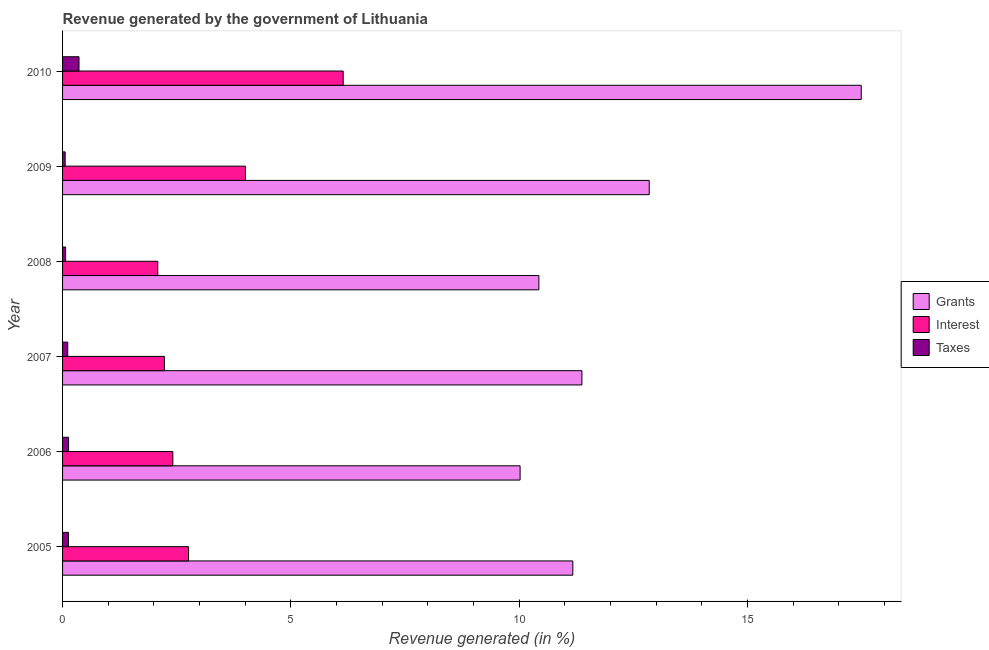How many different coloured bars are there?
Offer a terse response. 3. Are the number of bars on each tick of the Y-axis equal?
Your answer should be compact. Yes. What is the percentage of revenue generated by grants in 2006?
Provide a short and direct response. 10.02. Across all years, what is the maximum percentage of revenue generated by interest?
Make the answer very short. 6.15. Across all years, what is the minimum percentage of revenue generated by interest?
Keep it short and to the point. 2.09. In which year was the percentage of revenue generated by grants minimum?
Offer a terse response. 2006. What is the total percentage of revenue generated by grants in the graph?
Offer a terse response. 73.34. What is the difference between the percentage of revenue generated by grants in 2008 and that in 2009?
Keep it short and to the point. -2.42. What is the difference between the percentage of revenue generated by interest in 2006 and the percentage of revenue generated by grants in 2009?
Ensure brevity in your answer.  -10.43. What is the average percentage of revenue generated by taxes per year?
Offer a very short reply. 0.14. In the year 2005, what is the difference between the percentage of revenue generated by grants and percentage of revenue generated by taxes?
Offer a very short reply. 11.04. In how many years, is the percentage of revenue generated by taxes greater than 15 %?
Make the answer very short. 0. What is the ratio of the percentage of revenue generated by interest in 2005 to that in 2009?
Your answer should be very brief. 0.69. Is the percentage of revenue generated by grants in 2005 less than that in 2010?
Give a very brief answer. Yes. Is the difference between the percentage of revenue generated by taxes in 2007 and 2009 greater than the difference between the percentage of revenue generated by grants in 2007 and 2009?
Make the answer very short. Yes. What is the difference between the highest and the second highest percentage of revenue generated by interest?
Ensure brevity in your answer.  2.14. What is the difference between the highest and the lowest percentage of revenue generated by grants?
Provide a succinct answer. 7.47. In how many years, is the percentage of revenue generated by grants greater than the average percentage of revenue generated by grants taken over all years?
Keep it short and to the point. 2. What does the 3rd bar from the top in 2009 represents?
Your answer should be very brief. Grants. What does the 2nd bar from the bottom in 2006 represents?
Keep it short and to the point. Interest. How many bars are there?
Offer a very short reply. 18. Are all the bars in the graph horizontal?
Your answer should be compact. Yes. What is the difference between two consecutive major ticks on the X-axis?
Your response must be concise. 5. How many legend labels are there?
Give a very brief answer. 3. How are the legend labels stacked?
Your answer should be very brief. Vertical. What is the title of the graph?
Make the answer very short. Revenue generated by the government of Lithuania. Does "Industry" appear as one of the legend labels in the graph?
Your answer should be very brief. No. What is the label or title of the X-axis?
Provide a short and direct response. Revenue generated (in %). What is the label or title of the Y-axis?
Provide a succinct answer. Year. What is the Revenue generated (in %) in Grants in 2005?
Provide a succinct answer. 11.17. What is the Revenue generated (in %) in Interest in 2005?
Ensure brevity in your answer.  2.76. What is the Revenue generated (in %) in Taxes in 2005?
Offer a terse response. 0.13. What is the Revenue generated (in %) in Grants in 2006?
Your response must be concise. 10.02. What is the Revenue generated (in %) of Interest in 2006?
Offer a very short reply. 2.41. What is the Revenue generated (in %) of Taxes in 2006?
Your response must be concise. 0.13. What is the Revenue generated (in %) in Grants in 2007?
Give a very brief answer. 11.37. What is the Revenue generated (in %) in Interest in 2007?
Provide a succinct answer. 2.23. What is the Revenue generated (in %) in Taxes in 2007?
Offer a terse response. 0.11. What is the Revenue generated (in %) of Grants in 2008?
Your answer should be compact. 10.43. What is the Revenue generated (in %) in Interest in 2008?
Make the answer very short. 2.09. What is the Revenue generated (in %) of Taxes in 2008?
Give a very brief answer. 0.07. What is the Revenue generated (in %) of Grants in 2009?
Make the answer very short. 12.85. What is the Revenue generated (in %) of Interest in 2009?
Provide a short and direct response. 4. What is the Revenue generated (in %) in Taxes in 2009?
Provide a short and direct response. 0.06. What is the Revenue generated (in %) in Grants in 2010?
Your answer should be very brief. 17.49. What is the Revenue generated (in %) of Interest in 2010?
Provide a succinct answer. 6.15. What is the Revenue generated (in %) in Taxes in 2010?
Offer a terse response. 0.36. Across all years, what is the maximum Revenue generated (in %) in Grants?
Give a very brief answer. 17.49. Across all years, what is the maximum Revenue generated (in %) in Interest?
Ensure brevity in your answer.  6.15. Across all years, what is the maximum Revenue generated (in %) in Taxes?
Offer a very short reply. 0.36. Across all years, what is the minimum Revenue generated (in %) of Grants?
Provide a short and direct response. 10.02. Across all years, what is the minimum Revenue generated (in %) in Interest?
Make the answer very short. 2.09. Across all years, what is the minimum Revenue generated (in %) of Taxes?
Make the answer very short. 0.06. What is the total Revenue generated (in %) of Grants in the graph?
Provide a short and direct response. 73.34. What is the total Revenue generated (in %) of Interest in the graph?
Ensure brevity in your answer.  19.64. What is the total Revenue generated (in %) of Taxes in the graph?
Your answer should be very brief. 0.86. What is the difference between the Revenue generated (in %) in Grants in 2005 and that in 2006?
Your answer should be very brief. 1.15. What is the difference between the Revenue generated (in %) of Interest in 2005 and that in 2006?
Provide a succinct answer. 0.34. What is the difference between the Revenue generated (in %) in Taxes in 2005 and that in 2006?
Keep it short and to the point. -0. What is the difference between the Revenue generated (in %) of Grants in 2005 and that in 2007?
Give a very brief answer. -0.2. What is the difference between the Revenue generated (in %) of Interest in 2005 and that in 2007?
Your response must be concise. 0.53. What is the difference between the Revenue generated (in %) of Taxes in 2005 and that in 2007?
Ensure brevity in your answer.  0.02. What is the difference between the Revenue generated (in %) in Grants in 2005 and that in 2008?
Make the answer very short. 0.74. What is the difference between the Revenue generated (in %) of Interest in 2005 and that in 2008?
Keep it short and to the point. 0.67. What is the difference between the Revenue generated (in %) in Taxes in 2005 and that in 2008?
Keep it short and to the point. 0.06. What is the difference between the Revenue generated (in %) of Grants in 2005 and that in 2009?
Provide a succinct answer. -1.67. What is the difference between the Revenue generated (in %) in Interest in 2005 and that in 2009?
Make the answer very short. -1.25. What is the difference between the Revenue generated (in %) in Taxes in 2005 and that in 2009?
Make the answer very short. 0.07. What is the difference between the Revenue generated (in %) of Grants in 2005 and that in 2010?
Your response must be concise. -6.32. What is the difference between the Revenue generated (in %) in Interest in 2005 and that in 2010?
Keep it short and to the point. -3.39. What is the difference between the Revenue generated (in %) of Taxes in 2005 and that in 2010?
Make the answer very short. -0.23. What is the difference between the Revenue generated (in %) in Grants in 2006 and that in 2007?
Give a very brief answer. -1.35. What is the difference between the Revenue generated (in %) of Interest in 2006 and that in 2007?
Provide a succinct answer. 0.18. What is the difference between the Revenue generated (in %) of Taxes in 2006 and that in 2007?
Your response must be concise. 0.02. What is the difference between the Revenue generated (in %) in Grants in 2006 and that in 2008?
Provide a short and direct response. -0.41. What is the difference between the Revenue generated (in %) in Interest in 2006 and that in 2008?
Offer a very short reply. 0.33. What is the difference between the Revenue generated (in %) of Taxes in 2006 and that in 2008?
Provide a succinct answer. 0.06. What is the difference between the Revenue generated (in %) of Grants in 2006 and that in 2009?
Your response must be concise. -2.83. What is the difference between the Revenue generated (in %) of Interest in 2006 and that in 2009?
Offer a terse response. -1.59. What is the difference between the Revenue generated (in %) in Taxes in 2006 and that in 2009?
Give a very brief answer. 0.08. What is the difference between the Revenue generated (in %) in Grants in 2006 and that in 2010?
Your answer should be compact. -7.47. What is the difference between the Revenue generated (in %) of Interest in 2006 and that in 2010?
Keep it short and to the point. -3.73. What is the difference between the Revenue generated (in %) in Taxes in 2006 and that in 2010?
Offer a terse response. -0.23. What is the difference between the Revenue generated (in %) in Grants in 2007 and that in 2008?
Offer a very short reply. 0.94. What is the difference between the Revenue generated (in %) of Interest in 2007 and that in 2008?
Keep it short and to the point. 0.14. What is the difference between the Revenue generated (in %) of Taxes in 2007 and that in 2008?
Your response must be concise. 0.05. What is the difference between the Revenue generated (in %) of Grants in 2007 and that in 2009?
Give a very brief answer. -1.47. What is the difference between the Revenue generated (in %) in Interest in 2007 and that in 2009?
Offer a very short reply. -1.77. What is the difference between the Revenue generated (in %) in Taxes in 2007 and that in 2009?
Offer a very short reply. 0.06. What is the difference between the Revenue generated (in %) of Grants in 2007 and that in 2010?
Provide a succinct answer. -6.12. What is the difference between the Revenue generated (in %) of Interest in 2007 and that in 2010?
Your response must be concise. -3.92. What is the difference between the Revenue generated (in %) of Taxes in 2007 and that in 2010?
Make the answer very short. -0.25. What is the difference between the Revenue generated (in %) in Grants in 2008 and that in 2009?
Your answer should be very brief. -2.42. What is the difference between the Revenue generated (in %) of Interest in 2008 and that in 2009?
Offer a terse response. -1.92. What is the difference between the Revenue generated (in %) in Taxes in 2008 and that in 2009?
Offer a terse response. 0.01. What is the difference between the Revenue generated (in %) of Grants in 2008 and that in 2010?
Keep it short and to the point. -7.06. What is the difference between the Revenue generated (in %) of Interest in 2008 and that in 2010?
Your answer should be very brief. -4.06. What is the difference between the Revenue generated (in %) of Taxes in 2008 and that in 2010?
Make the answer very short. -0.29. What is the difference between the Revenue generated (in %) in Grants in 2009 and that in 2010?
Offer a terse response. -4.64. What is the difference between the Revenue generated (in %) of Interest in 2009 and that in 2010?
Your answer should be compact. -2.14. What is the difference between the Revenue generated (in %) in Taxes in 2009 and that in 2010?
Ensure brevity in your answer.  -0.3. What is the difference between the Revenue generated (in %) of Grants in 2005 and the Revenue generated (in %) of Interest in 2006?
Make the answer very short. 8.76. What is the difference between the Revenue generated (in %) in Grants in 2005 and the Revenue generated (in %) in Taxes in 2006?
Ensure brevity in your answer.  11.04. What is the difference between the Revenue generated (in %) in Interest in 2005 and the Revenue generated (in %) in Taxes in 2006?
Offer a very short reply. 2.63. What is the difference between the Revenue generated (in %) in Grants in 2005 and the Revenue generated (in %) in Interest in 2007?
Offer a terse response. 8.94. What is the difference between the Revenue generated (in %) in Grants in 2005 and the Revenue generated (in %) in Taxes in 2007?
Keep it short and to the point. 11.06. What is the difference between the Revenue generated (in %) in Interest in 2005 and the Revenue generated (in %) in Taxes in 2007?
Give a very brief answer. 2.65. What is the difference between the Revenue generated (in %) of Grants in 2005 and the Revenue generated (in %) of Interest in 2008?
Your answer should be compact. 9.09. What is the difference between the Revenue generated (in %) in Grants in 2005 and the Revenue generated (in %) in Taxes in 2008?
Your answer should be compact. 11.11. What is the difference between the Revenue generated (in %) of Interest in 2005 and the Revenue generated (in %) of Taxes in 2008?
Offer a very short reply. 2.69. What is the difference between the Revenue generated (in %) in Grants in 2005 and the Revenue generated (in %) in Interest in 2009?
Make the answer very short. 7.17. What is the difference between the Revenue generated (in %) of Grants in 2005 and the Revenue generated (in %) of Taxes in 2009?
Your answer should be very brief. 11.12. What is the difference between the Revenue generated (in %) of Interest in 2005 and the Revenue generated (in %) of Taxes in 2009?
Offer a terse response. 2.7. What is the difference between the Revenue generated (in %) in Grants in 2005 and the Revenue generated (in %) in Interest in 2010?
Keep it short and to the point. 5.03. What is the difference between the Revenue generated (in %) of Grants in 2005 and the Revenue generated (in %) of Taxes in 2010?
Provide a succinct answer. 10.81. What is the difference between the Revenue generated (in %) in Interest in 2005 and the Revenue generated (in %) in Taxes in 2010?
Your answer should be compact. 2.4. What is the difference between the Revenue generated (in %) in Grants in 2006 and the Revenue generated (in %) in Interest in 2007?
Give a very brief answer. 7.79. What is the difference between the Revenue generated (in %) of Grants in 2006 and the Revenue generated (in %) of Taxes in 2007?
Ensure brevity in your answer.  9.91. What is the difference between the Revenue generated (in %) in Interest in 2006 and the Revenue generated (in %) in Taxes in 2007?
Give a very brief answer. 2.3. What is the difference between the Revenue generated (in %) of Grants in 2006 and the Revenue generated (in %) of Interest in 2008?
Ensure brevity in your answer.  7.93. What is the difference between the Revenue generated (in %) in Grants in 2006 and the Revenue generated (in %) in Taxes in 2008?
Keep it short and to the point. 9.95. What is the difference between the Revenue generated (in %) in Interest in 2006 and the Revenue generated (in %) in Taxes in 2008?
Give a very brief answer. 2.35. What is the difference between the Revenue generated (in %) of Grants in 2006 and the Revenue generated (in %) of Interest in 2009?
Your response must be concise. 6.01. What is the difference between the Revenue generated (in %) in Grants in 2006 and the Revenue generated (in %) in Taxes in 2009?
Make the answer very short. 9.96. What is the difference between the Revenue generated (in %) of Interest in 2006 and the Revenue generated (in %) of Taxes in 2009?
Offer a terse response. 2.36. What is the difference between the Revenue generated (in %) in Grants in 2006 and the Revenue generated (in %) in Interest in 2010?
Ensure brevity in your answer.  3.87. What is the difference between the Revenue generated (in %) of Grants in 2006 and the Revenue generated (in %) of Taxes in 2010?
Offer a very short reply. 9.66. What is the difference between the Revenue generated (in %) of Interest in 2006 and the Revenue generated (in %) of Taxes in 2010?
Your answer should be very brief. 2.05. What is the difference between the Revenue generated (in %) of Grants in 2007 and the Revenue generated (in %) of Interest in 2008?
Provide a succinct answer. 9.29. What is the difference between the Revenue generated (in %) of Grants in 2007 and the Revenue generated (in %) of Taxes in 2008?
Provide a short and direct response. 11.31. What is the difference between the Revenue generated (in %) in Interest in 2007 and the Revenue generated (in %) in Taxes in 2008?
Make the answer very short. 2.16. What is the difference between the Revenue generated (in %) in Grants in 2007 and the Revenue generated (in %) in Interest in 2009?
Your response must be concise. 7.37. What is the difference between the Revenue generated (in %) of Grants in 2007 and the Revenue generated (in %) of Taxes in 2009?
Give a very brief answer. 11.32. What is the difference between the Revenue generated (in %) in Interest in 2007 and the Revenue generated (in %) in Taxes in 2009?
Your answer should be compact. 2.17. What is the difference between the Revenue generated (in %) in Grants in 2007 and the Revenue generated (in %) in Interest in 2010?
Provide a short and direct response. 5.23. What is the difference between the Revenue generated (in %) of Grants in 2007 and the Revenue generated (in %) of Taxes in 2010?
Offer a very short reply. 11.01. What is the difference between the Revenue generated (in %) in Interest in 2007 and the Revenue generated (in %) in Taxes in 2010?
Your response must be concise. 1.87. What is the difference between the Revenue generated (in %) of Grants in 2008 and the Revenue generated (in %) of Interest in 2009?
Keep it short and to the point. 6.43. What is the difference between the Revenue generated (in %) of Grants in 2008 and the Revenue generated (in %) of Taxes in 2009?
Provide a short and direct response. 10.37. What is the difference between the Revenue generated (in %) in Interest in 2008 and the Revenue generated (in %) in Taxes in 2009?
Your response must be concise. 2.03. What is the difference between the Revenue generated (in %) in Grants in 2008 and the Revenue generated (in %) in Interest in 2010?
Keep it short and to the point. 4.29. What is the difference between the Revenue generated (in %) in Grants in 2008 and the Revenue generated (in %) in Taxes in 2010?
Your response must be concise. 10.07. What is the difference between the Revenue generated (in %) of Interest in 2008 and the Revenue generated (in %) of Taxes in 2010?
Ensure brevity in your answer.  1.72. What is the difference between the Revenue generated (in %) in Grants in 2009 and the Revenue generated (in %) in Interest in 2010?
Provide a short and direct response. 6.7. What is the difference between the Revenue generated (in %) in Grants in 2009 and the Revenue generated (in %) in Taxes in 2010?
Make the answer very short. 12.49. What is the difference between the Revenue generated (in %) of Interest in 2009 and the Revenue generated (in %) of Taxes in 2010?
Ensure brevity in your answer.  3.64. What is the average Revenue generated (in %) of Grants per year?
Provide a succinct answer. 12.22. What is the average Revenue generated (in %) of Interest per year?
Make the answer very short. 3.27. What is the average Revenue generated (in %) of Taxes per year?
Your answer should be compact. 0.14. In the year 2005, what is the difference between the Revenue generated (in %) of Grants and Revenue generated (in %) of Interest?
Your response must be concise. 8.41. In the year 2005, what is the difference between the Revenue generated (in %) in Grants and Revenue generated (in %) in Taxes?
Offer a terse response. 11.05. In the year 2005, what is the difference between the Revenue generated (in %) in Interest and Revenue generated (in %) in Taxes?
Offer a very short reply. 2.63. In the year 2006, what is the difference between the Revenue generated (in %) in Grants and Revenue generated (in %) in Interest?
Your response must be concise. 7.61. In the year 2006, what is the difference between the Revenue generated (in %) in Grants and Revenue generated (in %) in Taxes?
Provide a succinct answer. 9.89. In the year 2006, what is the difference between the Revenue generated (in %) in Interest and Revenue generated (in %) in Taxes?
Provide a short and direct response. 2.28. In the year 2007, what is the difference between the Revenue generated (in %) in Grants and Revenue generated (in %) in Interest?
Offer a very short reply. 9.14. In the year 2007, what is the difference between the Revenue generated (in %) in Grants and Revenue generated (in %) in Taxes?
Your response must be concise. 11.26. In the year 2007, what is the difference between the Revenue generated (in %) in Interest and Revenue generated (in %) in Taxes?
Make the answer very short. 2.12. In the year 2008, what is the difference between the Revenue generated (in %) in Grants and Revenue generated (in %) in Interest?
Your answer should be very brief. 8.35. In the year 2008, what is the difference between the Revenue generated (in %) in Grants and Revenue generated (in %) in Taxes?
Your answer should be compact. 10.36. In the year 2008, what is the difference between the Revenue generated (in %) in Interest and Revenue generated (in %) in Taxes?
Your answer should be compact. 2.02. In the year 2009, what is the difference between the Revenue generated (in %) of Grants and Revenue generated (in %) of Interest?
Offer a terse response. 8.84. In the year 2009, what is the difference between the Revenue generated (in %) in Grants and Revenue generated (in %) in Taxes?
Make the answer very short. 12.79. In the year 2009, what is the difference between the Revenue generated (in %) in Interest and Revenue generated (in %) in Taxes?
Offer a terse response. 3.95. In the year 2010, what is the difference between the Revenue generated (in %) of Grants and Revenue generated (in %) of Interest?
Your answer should be compact. 11.35. In the year 2010, what is the difference between the Revenue generated (in %) of Grants and Revenue generated (in %) of Taxes?
Offer a terse response. 17.13. In the year 2010, what is the difference between the Revenue generated (in %) of Interest and Revenue generated (in %) of Taxes?
Offer a very short reply. 5.79. What is the ratio of the Revenue generated (in %) in Grants in 2005 to that in 2006?
Your answer should be very brief. 1.12. What is the ratio of the Revenue generated (in %) in Interest in 2005 to that in 2006?
Give a very brief answer. 1.14. What is the ratio of the Revenue generated (in %) in Taxes in 2005 to that in 2006?
Provide a succinct answer. 0.98. What is the ratio of the Revenue generated (in %) of Grants in 2005 to that in 2007?
Provide a succinct answer. 0.98. What is the ratio of the Revenue generated (in %) of Interest in 2005 to that in 2007?
Offer a very short reply. 1.24. What is the ratio of the Revenue generated (in %) in Taxes in 2005 to that in 2007?
Your answer should be compact. 1.14. What is the ratio of the Revenue generated (in %) of Grants in 2005 to that in 2008?
Provide a short and direct response. 1.07. What is the ratio of the Revenue generated (in %) in Interest in 2005 to that in 2008?
Offer a very short reply. 1.32. What is the ratio of the Revenue generated (in %) of Taxes in 2005 to that in 2008?
Keep it short and to the point. 1.91. What is the ratio of the Revenue generated (in %) of Grants in 2005 to that in 2009?
Ensure brevity in your answer.  0.87. What is the ratio of the Revenue generated (in %) of Interest in 2005 to that in 2009?
Make the answer very short. 0.69. What is the ratio of the Revenue generated (in %) in Taxes in 2005 to that in 2009?
Give a very brief answer. 2.28. What is the ratio of the Revenue generated (in %) in Grants in 2005 to that in 2010?
Provide a succinct answer. 0.64. What is the ratio of the Revenue generated (in %) of Interest in 2005 to that in 2010?
Provide a succinct answer. 0.45. What is the ratio of the Revenue generated (in %) in Taxes in 2005 to that in 2010?
Make the answer very short. 0.36. What is the ratio of the Revenue generated (in %) of Grants in 2006 to that in 2007?
Ensure brevity in your answer.  0.88. What is the ratio of the Revenue generated (in %) in Interest in 2006 to that in 2007?
Your answer should be very brief. 1.08. What is the ratio of the Revenue generated (in %) of Taxes in 2006 to that in 2007?
Your answer should be very brief. 1.16. What is the ratio of the Revenue generated (in %) in Grants in 2006 to that in 2008?
Your answer should be very brief. 0.96. What is the ratio of the Revenue generated (in %) in Interest in 2006 to that in 2008?
Ensure brevity in your answer.  1.16. What is the ratio of the Revenue generated (in %) of Taxes in 2006 to that in 2008?
Offer a terse response. 1.96. What is the ratio of the Revenue generated (in %) in Grants in 2006 to that in 2009?
Your answer should be very brief. 0.78. What is the ratio of the Revenue generated (in %) of Interest in 2006 to that in 2009?
Your answer should be compact. 0.6. What is the ratio of the Revenue generated (in %) in Taxes in 2006 to that in 2009?
Ensure brevity in your answer.  2.33. What is the ratio of the Revenue generated (in %) of Grants in 2006 to that in 2010?
Provide a short and direct response. 0.57. What is the ratio of the Revenue generated (in %) of Interest in 2006 to that in 2010?
Your answer should be very brief. 0.39. What is the ratio of the Revenue generated (in %) in Taxes in 2006 to that in 2010?
Make the answer very short. 0.37. What is the ratio of the Revenue generated (in %) of Grants in 2007 to that in 2008?
Give a very brief answer. 1.09. What is the ratio of the Revenue generated (in %) of Interest in 2007 to that in 2008?
Provide a short and direct response. 1.07. What is the ratio of the Revenue generated (in %) of Taxes in 2007 to that in 2008?
Provide a short and direct response. 1.68. What is the ratio of the Revenue generated (in %) in Grants in 2007 to that in 2009?
Ensure brevity in your answer.  0.89. What is the ratio of the Revenue generated (in %) in Interest in 2007 to that in 2009?
Offer a terse response. 0.56. What is the ratio of the Revenue generated (in %) of Taxes in 2007 to that in 2009?
Offer a terse response. 2. What is the ratio of the Revenue generated (in %) of Grants in 2007 to that in 2010?
Your answer should be compact. 0.65. What is the ratio of the Revenue generated (in %) of Interest in 2007 to that in 2010?
Provide a succinct answer. 0.36. What is the ratio of the Revenue generated (in %) in Taxes in 2007 to that in 2010?
Provide a short and direct response. 0.31. What is the ratio of the Revenue generated (in %) in Grants in 2008 to that in 2009?
Ensure brevity in your answer.  0.81. What is the ratio of the Revenue generated (in %) of Interest in 2008 to that in 2009?
Provide a succinct answer. 0.52. What is the ratio of the Revenue generated (in %) in Taxes in 2008 to that in 2009?
Give a very brief answer. 1.19. What is the ratio of the Revenue generated (in %) of Grants in 2008 to that in 2010?
Your response must be concise. 0.6. What is the ratio of the Revenue generated (in %) in Interest in 2008 to that in 2010?
Provide a short and direct response. 0.34. What is the ratio of the Revenue generated (in %) of Taxes in 2008 to that in 2010?
Your response must be concise. 0.19. What is the ratio of the Revenue generated (in %) of Grants in 2009 to that in 2010?
Give a very brief answer. 0.73. What is the ratio of the Revenue generated (in %) of Interest in 2009 to that in 2010?
Ensure brevity in your answer.  0.65. What is the ratio of the Revenue generated (in %) in Taxes in 2009 to that in 2010?
Provide a succinct answer. 0.16. What is the difference between the highest and the second highest Revenue generated (in %) in Grants?
Provide a short and direct response. 4.64. What is the difference between the highest and the second highest Revenue generated (in %) in Interest?
Ensure brevity in your answer.  2.14. What is the difference between the highest and the second highest Revenue generated (in %) in Taxes?
Your answer should be compact. 0.23. What is the difference between the highest and the lowest Revenue generated (in %) in Grants?
Make the answer very short. 7.47. What is the difference between the highest and the lowest Revenue generated (in %) of Interest?
Provide a short and direct response. 4.06. What is the difference between the highest and the lowest Revenue generated (in %) of Taxes?
Your answer should be very brief. 0.3. 